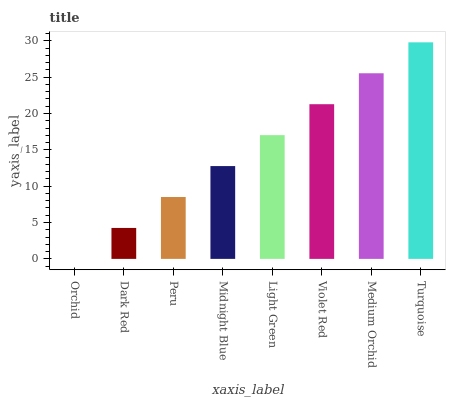Is Orchid the minimum?
Answer yes or no. Yes. Is Turquoise the maximum?
Answer yes or no. Yes. Is Dark Red the minimum?
Answer yes or no. No. Is Dark Red the maximum?
Answer yes or no. No. Is Dark Red greater than Orchid?
Answer yes or no. Yes. Is Orchid less than Dark Red?
Answer yes or no. Yes. Is Orchid greater than Dark Red?
Answer yes or no. No. Is Dark Red less than Orchid?
Answer yes or no. No. Is Light Green the high median?
Answer yes or no. Yes. Is Midnight Blue the low median?
Answer yes or no. Yes. Is Peru the high median?
Answer yes or no. No. Is Medium Orchid the low median?
Answer yes or no. No. 